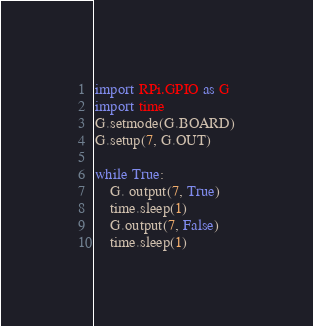<code> <loc_0><loc_0><loc_500><loc_500><_Python_>import RPi.GPIO as G
import time
G.setmode(G.BOARD)
G.setup(7, G.OUT)

while True:  
	G. output(7, True)
	time.sleep(1)
	G.output(7, False)
	time.sleep(1)
</code> 